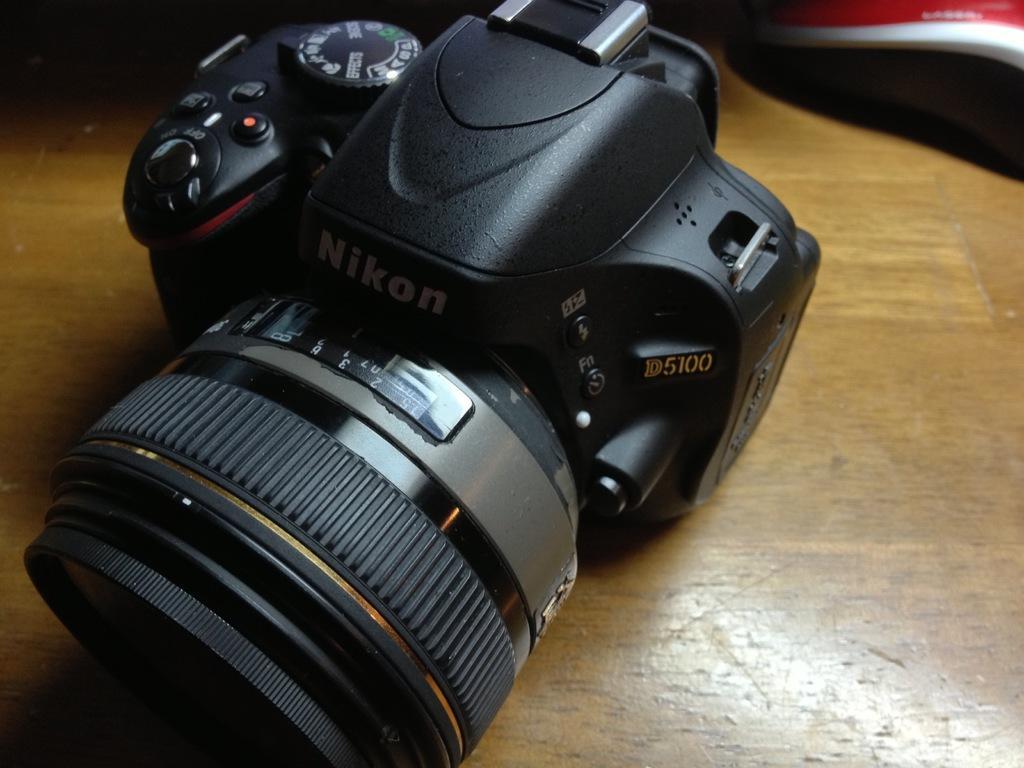Could you give a brief overview of what you see in this image? In this image in the front there is a camera which is black in colour which is on the brown colour surface and there is some text written on the camera and at the top right of the image there is an object which is red and black in colour. 